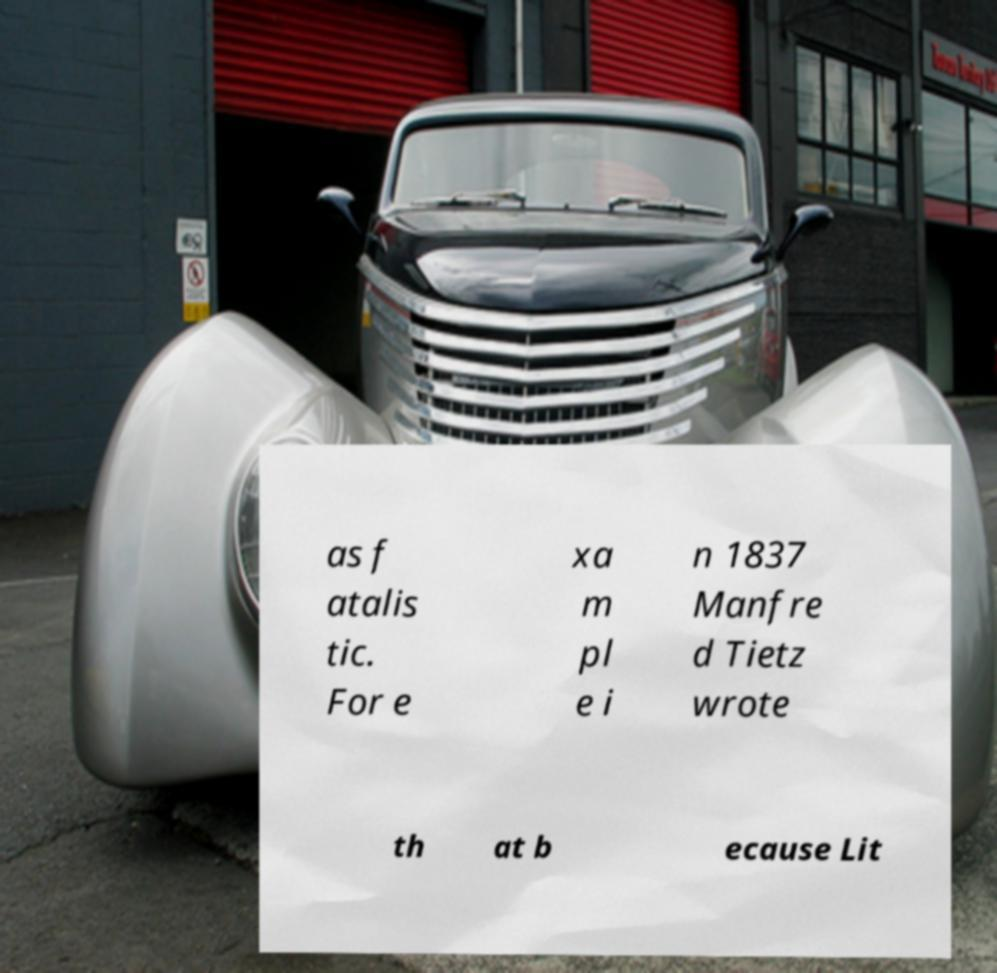Can you accurately transcribe the text from the provided image for me? as f atalis tic. For e xa m pl e i n 1837 Manfre d Tietz wrote th at b ecause Lit 